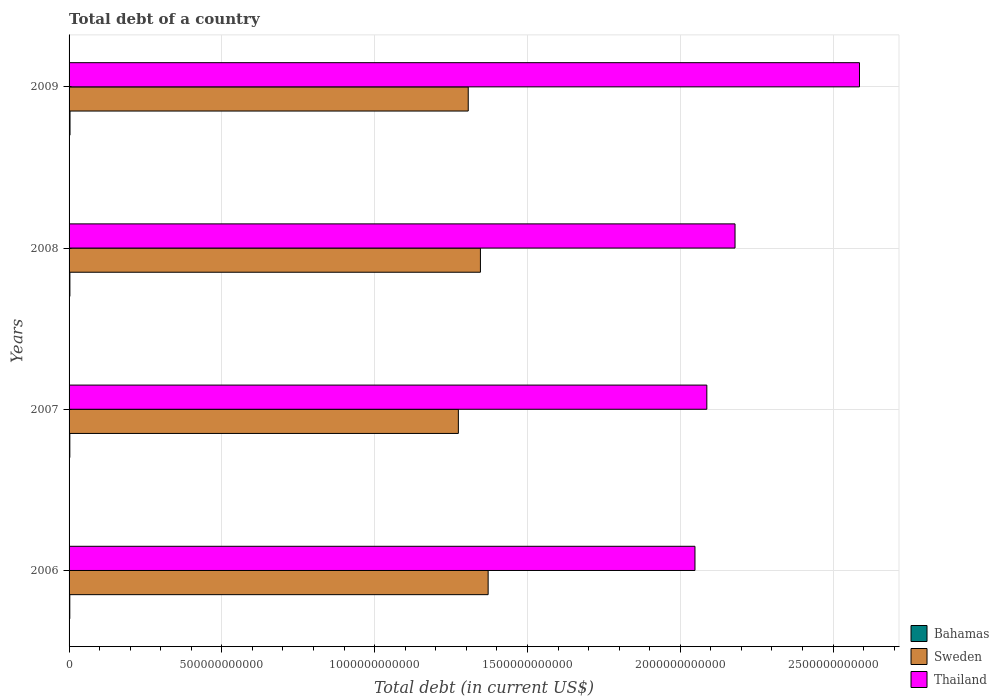How many different coloured bars are there?
Offer a very short reply. 3. Are the number of bars on each tick of the Y-axis equal?
Keep it short and to the point. Yes. How many bars are there on the 1st tick from the top?
Keep it short and to the point. 3. How many bars are there on the 2nd tick from the bottom?
Ensure brevity in your answer.  3. What is the debt in Bahamas in 2007?
Provide a succinct answer. 2.47e+09. Across all years, what is the maximum debt in Thailand?
Give a very brief answer. 2.59e+12. Across all years, what is the minimum debt in Thailand?
Your answer should be very brief. 2.05e+12. In which year was the debt in Bahamas maximum?
Offer a terse response. 2009. In which year was the debt in Thailand minimum?
Provide a succinct answer. 2006. What is the total debt in Sweden in the graph?
Your response must be concise. 5.30e+12. What is the difference between the debt in Sweden in 2006 and that in 2008?
Provide a short and direct response. 2.53e+1. What is the difference between the debt in Thailand in 2008 and the debt in Sweden in 2007?
Give a very brief answer. 9.05e+11. What is the average debt in Bahamas per year?
Offer a very short reply. 2.65e+09. In the year 2008, what is the difference between the debt in Bahamas and debt in Sweden?
Provide a short and direct response. -1.34e+12. What is the ratio of the debt in Sweden in 2006 to that in 2007?
Offer a very short reply. 1.08. What is the difference between the highest and the second highest debt in Sweden?
Provide a succinct answer. 2.53e+1. What is the difference between the highest and the lowest debt in Bahamas?
Keep it short and to the point. 6.98e+08. In how many years, is the debt in Thailand greater than the average debt in Thailand taken over all years?
Ensure brevity in your answer.  1. What does the 3rd bar from the bottom in 2009 represents?
Offer a very short reply. Thailand. Is it the case that in every year, the sum of the debt in Bahamas and debt in Thailand is greater than the debt in Sweden?
Provide a short and direct response. Yes. How many bars are there?
Offer a very short reply. 12. Are all the bars in the graph horizontal?
Your response must be concise. Yes. What is the difference between two consecutive major ticks on the X-axis?
Provide a short and direct response. 5.00e+11. Are the values on the major ticks of X-axis written in scientific E-notation?
Offer a terse response. No. How many legend labels are there?
Provide a succinct answer. 3. How are the legend labels stacked?
Offer a terse response. Vertical. What is the title of the graph?
Offer a terse response. Total debt of a country. What is the label or title of the X-axis?
Ensure brevity in your answer.  Total debt (in current US$). What is the label or title of the Y-axis?
Ensure brevity in your answer.  Years. What is the Total debt (in current US$) of Bahamas in 2006?
Your response must be concise. 2.39e+09. What is the Total debt (in current US$) of Sweden in 2006?
Offer a very short reply. 1.37e+12. What is the Total debt (in current US$) in Thailand in 2006?
Your response must be concise. 2.05e+12. What is the Total debt (in current US$) of Bahamas in 2007?
Give a very brief answer. 2.47e+09. What is the Total debt (in current US$) of Sweden in 2007?
Offer a terse response. 1.27e+12. What is the Total debt (in current US$) in Thailand in 2007?
Offer a very short reply. 2.09e+12. What is the Total debt (in current US$) in Bahamas in 2008?
Provide a succinct answer. 2.68e+09. What is the Total debt (in current US$) in Sweden in 2008?
Ensure brevity in your answer.  1.35e+12. What is the Total debt (in current US$) in Thailand in 2008?
Offer a terse response. 2.18e+12. What is the Total debt (in current US$) in Bahamas in 2009?
Your response must be concise. 3.08e+09. What is the Total debt (in current US$) in Sweden in 2009?
Your response must be concise. 1.31e+12. What is the Total debt (in current US$) in Thailand in 2009?
Keep it short and to the point. 2.59e+12. Across all years, what is the maximum Total debt (in current US$) of Bahamas?
Offer a very short reply. 3.08e+09. Across all years, what is the maximum Total debt (in current US$) in Sweden?
Give a very brief answer. 1.37e+12. Across all years, what is the maximum Total debt (in current US$) in Thailand?
Your answer should be very brief. 2.59e+12. Across all years, what is the minimum Total debt (in current US$) in Bahamas?
Make the answer very short. 2.39e+09. Across all years, what is the minimum Total debt (in current US$) in Sweden?
Ensure brevity in your answer.  1.27e+12. Across all years, what is the minimum Total debt (in current US$) in Thailand?
Provide a succinct answer. 2.05e+12. What is the total Total debt (in current US$) in Bahamas in the graph?
Offer a very short reply. 1.06e+1. What is the total Total debt (in current US$) of Sweden in the graph?
Make the answer very short. 5.30e+12. What is the total Total debt (in current US$) in Thailand in the graph?
Make the answer very short. 8.90e+12. What is the difference between the Total debt (in current US$) in Bahamas in 2006 and that in 2007?
Your answer should be compact. -8.30e+07. What is the difference between the Total debt (in current US$) in Sweden in 2006 and that in 2007?
Keep it short and to the point. 9.75e+1. What is the difference between the Total debt (in current US$) in Thailand in 2006 and that in 2007?
Offer a very short reply. -3.88e+1. What is the difference between the Total debt (in current US$) of Bahamas in 2006 and that in 2008?
Provide a succinct answer. -2.93e+08. What is the difference between the Total debt (in current US$) of Sweden in 2006 and that in 2008?
Keep it short and to the point. 2.53e+1. What is the difference between the Total debt (in current US$) in Thailand in 2006 and that in 2008?
Offer a terse response. -1.31e+11. What is the difference between the Total debt (in current US$) in Bahamas in 2006 and that in 2009?
Your answer should be compact. -6.98e+08. What is the difference between the Total debt (in current US$) of Sweden in 2006 and that in 2009?
Offer a terse response. 6.51e+1. What is the difference between the Total debt (in current US$) in Thailand in 2006 and that in 2009?
Provide a short and direct response. -5.38e+11. What is the difference between the Total debt (in current US$) of Bahamas in 2007 and that in 2008?
Your answer should be compact. -2.10e+08. What is the difference between the Total debt (in current US$) in Sweden in 2007 and that in 2008?
Keep it short and to the point. -7.22e+1. What is the difference between the Total debt (in current US$) in Thailand in 2007 and that in 2008?
Your answer should be compact. -9.23e+1. What is the difference between the Total debt (in current US$) in Bahamas in 2007 and that in 2009?
Provide a short and direct response. -6.15e+08. What is the difference between the Total debt (in current US$) in Sweden in 2007 and that in 2009?
Offer a terse response. -3.23e+1. What is the difference between the Total debt (in current US$) of Thailand in 2007 and that in 2009?
Offer a terse response. -5.00e+11. What is the difference between the Total debt (in current US$) of Bahamas in 2008 and that in 2009?
Your response must be concise. -4.06e+08. What is the difference between the Total debt (in current US$) of Sweden in 2008 and that in 2009?
Ensure brevity in your answer.  3.99e+1. What is the difference between the Total debt (in current US$) of Thailand in 2008 and that in 2009?
Provide a short and direct response. -4.07e+11. What is the difference between the Total debt (in current US$) of Bahamas in 2006 and the Total debt (in current US$) of Sweden in 2007?
Your response must be concise. -1.27e+12. What is the difference between the Total debt (in current US$) in Bahamas in 2006 and the Total debt (in current US$) in Thailand in 2007?
Provide a short and direct response. -2.08e+12. What is the difference between the Total debt (in current US$) in Sweden in 2006 and the Total debt (in current US$) in Thailand in 2007?
Offer a very short reply. -7.16e+11. What is the difference between the Total debt (in current US$) in Bahamas in 2006 and the Total debt (in current US$) in Sweden in 2008?
Your answer should be very brief. -1.34e+12. What is the difference between the Total debt (in current US$) in Bahamas in 2006 and the Total debt (in current US$) in Thailand in 2008?
Provide a short and direct response. -2.18e+12. What is the difference between the Total debt (in current US$) of Sweden in 2006 and the Total debt (in current US$) of Thailand in 2008?
Provide a succinct answer. -8.08e+11. What is the difference between the Total debt (in current US$) of Bahamas in 2006 and the Total debt (in current US$) of Sweden in 2009?
Your response must be concise. -1.30e+12. What is the difference between the Total debt (in current US$) of Bahamas in 2006 and the Total debt (in current US$) of Thailand in 2009?
Your answer should be very brief. -2.58e+12. What is the difference between the Total debt (in current US$) of Sweden in 2006 and the Total debt (in current US$) of Thailand in 2009?
Keep it short and to the point. -1.22e+12. What is the difference between the Total debt (in current US$) in Bahamas in 2007 and the Total debt (in current US$) in Sweden in 2008?
Provide a succinct answer. -1.34e+12. What is the difference between the Total debt (in current US$) of Bahamas in 2007 and the Total debt (in current US$) of Thailand in 2008?
Provide a short and direct response. -2.18e+12. What is the difference between the Total debt (in current US$) in Sweden in 2007 and the Total debt (in current US$) in Thailand in 2008?
Offer a very short reply. -9.05e+11. What is the difference between the Total debt (in current US$) of Bahamas in 2007 and the Total debt (in current US$) of Sweden in 2009?
Offer a very short reply. -1.30e+12. What is the difference between the Total debt (in current US$) in Bahamas in 2007 and the Total debt (in current US$) in Thailand in 2009?
Offer a very short reply. -2.58e+12. What is the difference between the Total debt (in current US$) of Sweden in 2007 and the Total debt (in current US$) of Thailand in 2009?
Your answer should be compact. -1.31e+12. What is the difference between the Total debt (in current US$) in Bahamas in 2008 and the Total debt (in current US$) in Sweden in 2009?
Your response must be concise. -1.30e+12. What is the difference between the Total debt (in current US$) of Bahamas in 2008 and the Total debt (in current US$) of Thailand in 2009?
Make the answer very short. -2.58e+12. What is the difference between the Total debt (in current US$) in Sweden in 2008 and the Total debt (in current US$) in Thailand in 2009?
Provide a succinct answer. -1.24e+12. What is the average Total debt (in current US$) in Bahamas per year?
Offer a terse response. 2.65e+09. What is the average Total debt (in current US$) of Sweden per year?
Your answer should be very brief. 1.32e+12. What is the average Total debt (in current US$) of Thailand per year?
Offer a terse response. 2.23e+12. In the year 2006, what is the difference between the Total debt (in current US$) of Bahamas and Total debt (in current US$) of Sweden?
Your response must be concise. -1.37e+12. In the year 2006, what is the difference between the Total debt (in current US$) of Bahamas and Total debt (in current US$) of Thailand?
Make the answer very short. -2.05e+12. In the year 2006, what is the difference between the Total debt (in current US$) of Sweden and Total debt (in current US$) of Thailand?
Offer a terse response. -6.77e+11. In the year 2007, what is the difference between the Total debt (in current US$) of Bahamas and Total debt (in current US$) of Sweden?
Offer a terse response. -1.27e+12. In the year 2007, what is the difference between the Total debt (in current US$) of Bahamas and Total debt (in current US$) of Thailand?
Your response must be concise. -2.08e+12. In the year 2007, what is the difference between the Total debt (in current US$) of Sweden and Total debt (in current US$) of Thailand?
Provide a short and direct response. -8.13e+11. In the year 2008, what is the difference between the Total debt (in current US$) of Bahamas and Total debt (in current US$) of Sweden?
Give a very brief answer. -1.34e+12. In the year 2008, what is the difference between the Total debt (in current US$) in Bahamas and Total debt (in current US$) in Thailand?
Keep it short and to the point. -2.18e+12. In the year 2008, what is the difference between the Total debt (in current US$) of Sweden and Total debt (in current US$) of Thailand?
Make the answer very short. -8.33e+11. In the year 2009, what is the difference between the Total debt (in current US$) in Bahamas and Total debt (in current US$) in Sweden?
Offer a terse response. -1.30e+12. In the year 2009, what is the difference between the Total debt (in current US$) of Bahamas and Total debt (in current US$) of Thailand?
Keep it short and to the point. -2.58e+12. In the year 2009, what is the difference between the Total debt (in current US$) of Sweden and Total debt (in current US$) of Thailand?
Give a very brief answer. -1.28e+12. What is the ratio of the Total debt (in current US$) of Bahamas in 2006 to that in 2007?
Make the answer very short. 0.97. What is the ratio of the Total debt (in current US$) of Sweden in 2006 to that in 2007?
Give a very brief answer. 1.08. What is the ratio of the Total debt (in current US$) of Thailand in 2006 to that in 2007?
Your response must be concise. 0.98. What is the ratio of the Total debt (in current US$) of Bahamas in 2006 to that in 2008?
Your answer should be very brief. 0.89. What is the ratio of the Total debt (in current US$) in Sweden in 2006 to that in 2008?
Offer a very short reply. 1.02. What is the ratio of the Total debt (in current US$) of Thailand in 2006 to that in 2008?
Provide a short and direct response. 0.94. What is the ratio of the Total debt (in current US$) in Bahamas in 2006 to that in 2009?
Your response must be concise. 0.77. What is the ratio of the Total debt (in current US$) in Sweden in 2006 to that in 2009?
Your response must be concise. 1.05. What is the ratio of the Total debt (in current US$) in Thailand in 2006 to that in 2009?
Give a very brief answer. 0.79. What is the ratio of the Total debt (in current US$) in Bahamas in 2007 to that in 2008?
Your answer should be very brief. 0.92. What is the ratio of the Total debt (in current US$) of Sweden in 2007 to that in 2008?
Offer a very short reply. 0.95. What is the ratio of the Total debt (in current US$) of Thailand in 2007 to that in 2008?
Give a very brief answer. 0.96. What is the ratio of the Total debt (in current US$) of Bahamas in 2007 to that in 2009?
Provide a short and direct response. 0.8. What is the ratio of the Total debt (in current US$) in Sweden in 2007 to that in 2009?
Provide a succinct answer. 0.98. What is the ratio of the Total debt (in current US$) in Thailand in 2007 to that in 2009?
Your response must be concise. 0.81. What is the ratio of the Total debt (in current US$) of Bahamas in 2008 to that in 2009?
Ensure brevity in your answer.  0.87. What is the ratio of the Total debt (in current US$) in Sweden in 2008 to that in 2009?
Make the answer very short. 1.03. What is the ratio of the Total debt (in current US$) in Thailand in 2008 to that in 2009?
Your answer should be compact. 0.84. What is the difference between the highest and the second highest Total debt (in current US$) of Bahamas?
Offer a terse response. 4.06e+08. What is the difference between the highest and the second highest Total debt (in current US$) of Sweden?
Give a very brief answer. 2.53e+1. What is the difference between the highest and the second highest Total debt (in current US$) in Thailand?
Your response must be concise. 4.07e+11. What is the difference between the highest and the lowest Total debt (in current US$) of Bahamas?
Your answer should be very brief. 6.98e+08. What is the difference between the highest and the lowest Total debt (in current US$) of Sweden?
Offer a terse response. 9.75e+1. What is the difference between the highest and the lowest Total debt (in current US$) of Thailand?
Keep it short and to the point. 5.38e+11. 